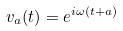Convert formula to latex. <formula><loc_0><loc_0><loc_500><loc_500>v _ { a } ( t ) = e ^ { i \omega ( t + a ) }</formula> 